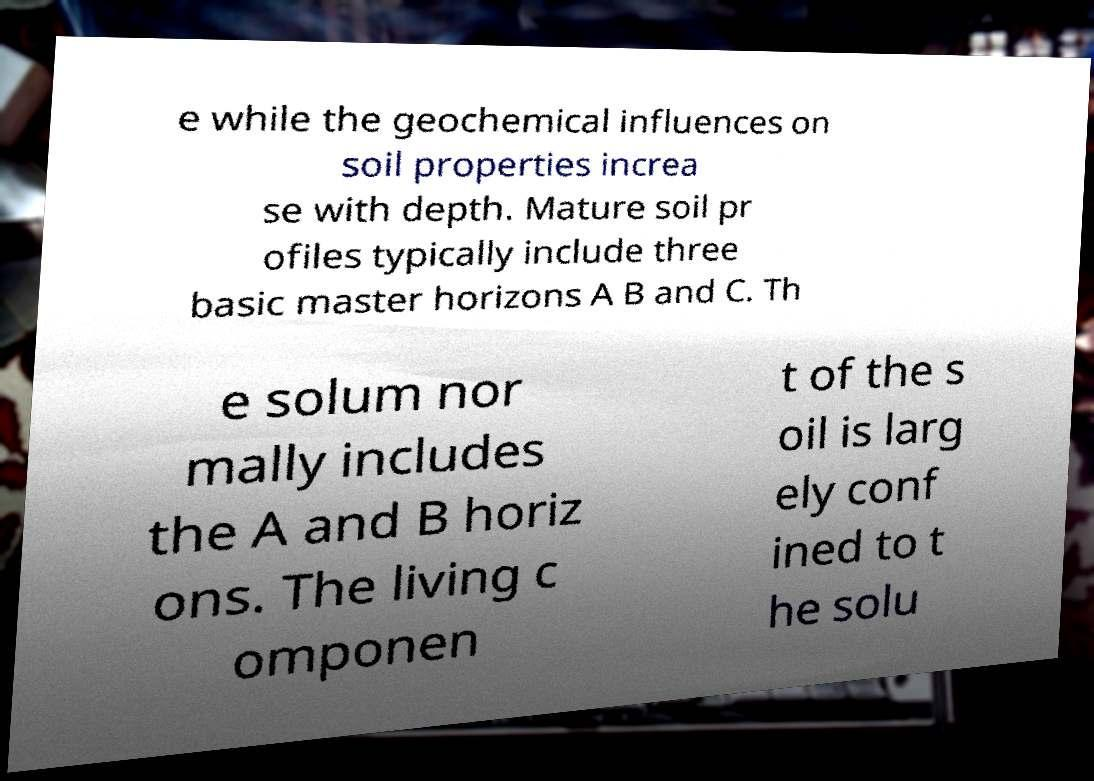Please read and relay the text visible in this image. What does it say? e while the geochemical influences on soil properties increa se with depth. Mature soil pr ofiles typically include three basic master horizons A B and C. Th e solum nor mally includes the A and B horiz ons. The living c omponen t of the s oil is larg ely conf ined to t he solu 